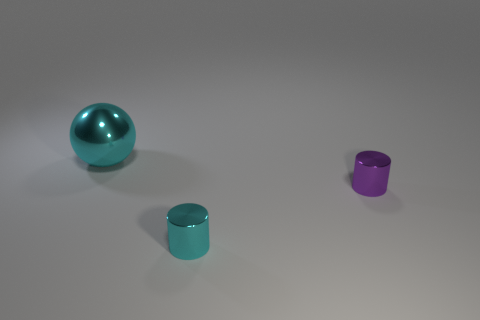What number of tiny purple shiny things are in front of the small shiny object to the right of the cyan object that is in front of the large cyan metal object?
Offer a very short reply. 0. Do the shiny cylinder on the left side of the purple metallic cylinder and the ball behind the tiny purple shiny object have the same size?
Your answer should be very brief. No. There is another tiny thing that is the same shape as the purple object; what is it made of?
Give a very brief answer. Metal. How many big things are purple cylinders or cyan cylinders?
Give a very brief answer. 0. What material is the cyan cylinder?
Provide a short and direct response. Metal. The thing that is both on the left side of the small purple shiny cylinder and to the right of the big sphere is made of what material?
Make the answer very short. Metal. There is a shiny ball; does it have the same color as the small cylinder to the left of the small purple thing?
Offer a very short reply. Yes. There is another cylinder that is the same size as the purple cylinder; what material is it?
Make the answer very short. Metal. Is there another big cyan sphere made of the same material as the big cyan sphere?
Provide a succinct answer. No. How many purple shiny objects are there?
Offer a terse response. 1. 